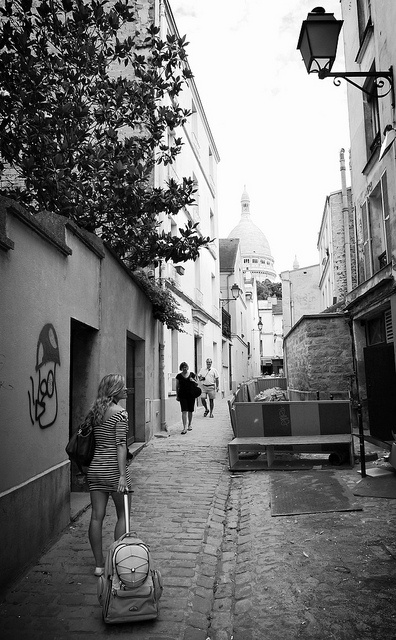Describe the objects in this image and their specific colors. I can see people in lightgray, black, gray, and darkgray tones, suitcase in lightgray, gray, black, and darkgray tones, bench in lightgray, black, and gray tones, handbag in black, gray, and lightgray tones, and people in lightgray, black, gray, and darkgray tones in this image. 